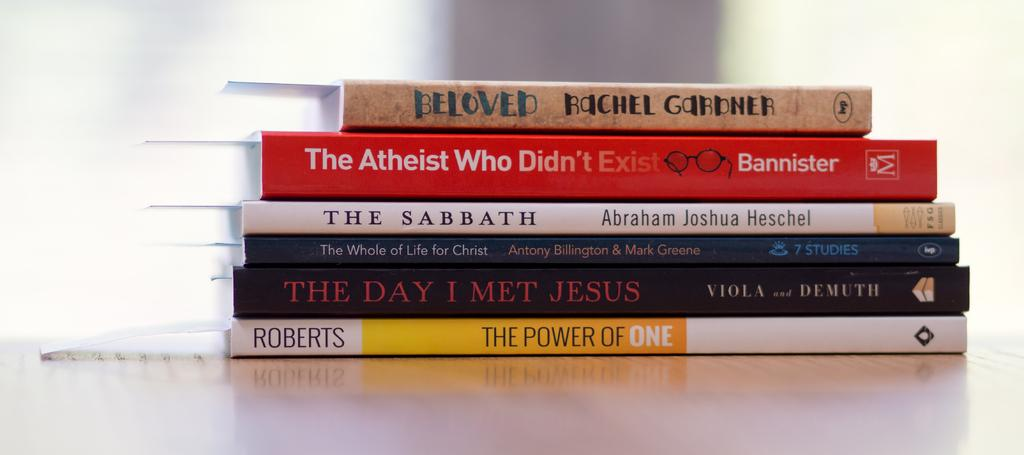<image>
Present a compact description of the photo's key features. Six books are stacked on top of each other and all deal with religion such as the one called The Sabbath and another The Day I Met Jesus. 